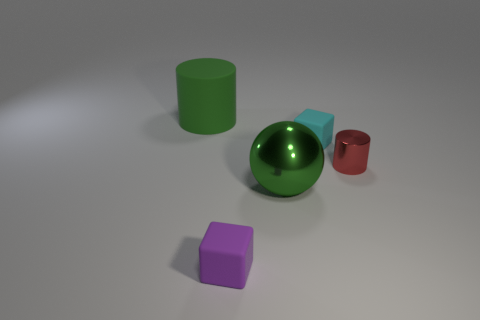Subtract 1 cubes. How many cubes are left? 1 Add 4 blue metal things. How many objects exist? 9 Subtract all red cylinders. How many cylinders are left? 1 Add 5 small cyan rubber things. How many small cyan rubber things are left? 6 Add 3 big matte cylinders. How many big matte cylinders exist? 4 Subtract 0 purple cylinders. How many objects are left? 5 Subtract all spheres. How many objects are left? 4 Subtract all cyan spheres. Subtract all purple cylinders. How many spheres are left? 1 Subtract all green blocks. How many red spheres are left? 0 Subtract all purple things. Subtract all tiny things. How many objects are left? 1 